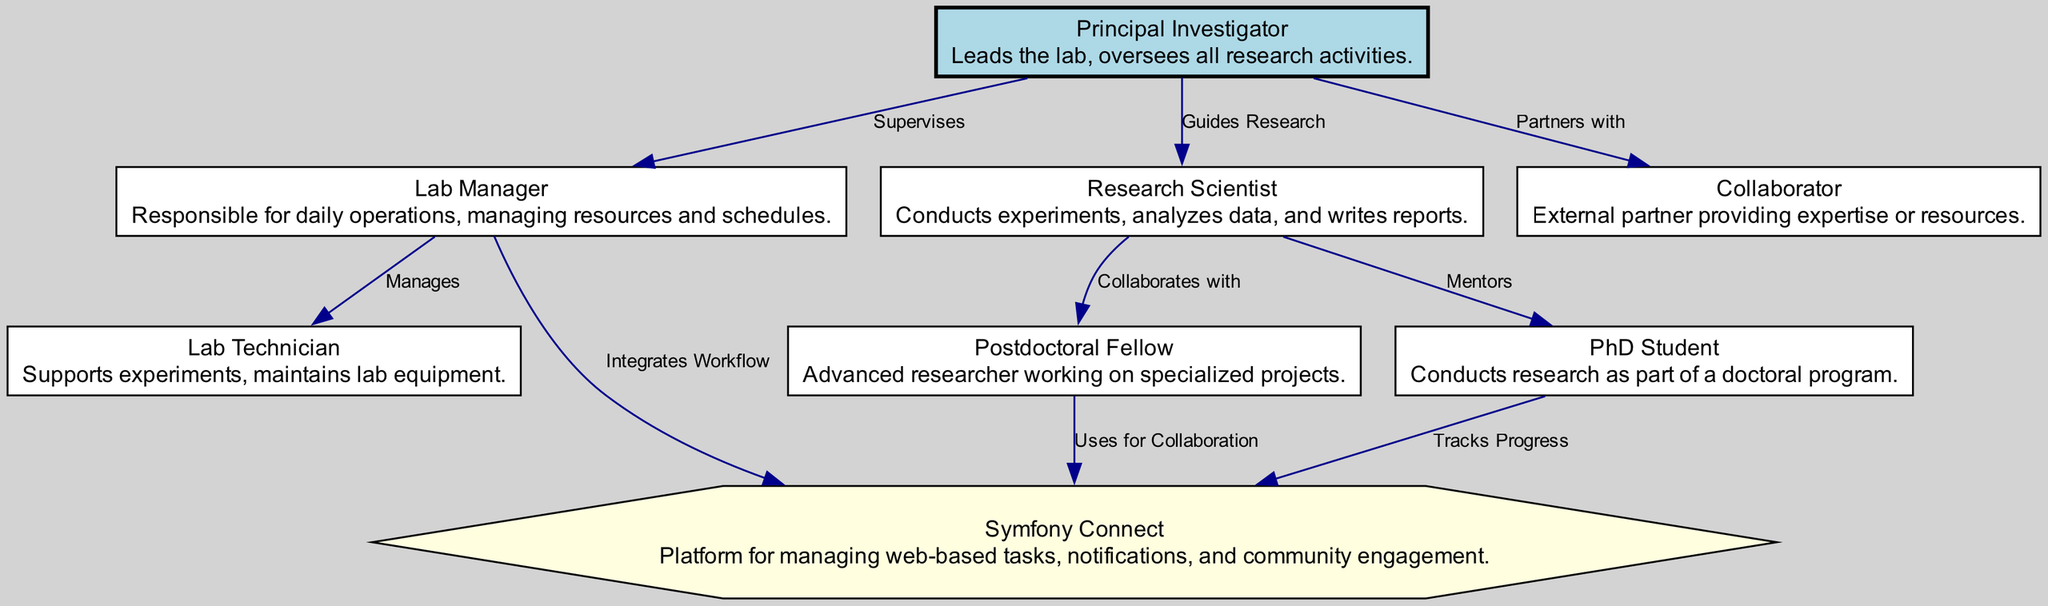What is the role of the Principal Investigator? The diagram explicitly states that the Principal Investigator "Leads the lab, oversees all research activities." Therefore, the answer is directly drawn from the role description next to this node.
Answer: Leads the lab, oversees all research activities How many nodes are present in the diagram? By counting the nodes listed in the "nodes" section of the data, we find there are 8 unique identifiers, each representing different roles within the lab structure. This count gives us the total number of nodes in the diagram.
Answer: 8 Who does the Lab Manager manage? The diagram indicates that the Lab Manager "Manages" the Lab Technician, establishing a direct relationship where the Lab Manager is responsible for overseeing the Lab Technician's work and activities.
Answer: Lab Technician What is the relationship between the Principal Investigator and the Collaborator? The diagram specifies that the Principal Investigator "Partners with" the Collaborator, indicating a collaborative relationship where both parties work together. This is explicitly articulated in the edges section where this connection is detailed.
Answer: Partners with Which node uses Symphony Connect for collaboration? According to the diagram, it states that the Postdoctoral Fellow "Uses for Collaboration" in relation to Symphony Connect, indicating their use of this platform for collaborative purposes and interactions.
Answer: Postdoctoral Fellow How many connections (edges) are there in the diagram? By reviewing the edges detailed in the data, we count a total of 8 connections that illustrate the relationships and workflows between different roles in the lab structure.
Answer: 8 Which role tracks progress using Symphony Connect? The role of the PhD Student is directly indicated in the diagram as one that "Tracks Progress" using Symphony Connect, showing their engagement with this platform for managing their research workflow.
Answer: PhD Student Who does the Research Scientist mentor? The diagram reveals the connection where the Research Scientist "Mentors" the PhD Student, indicating a guiding role the Research Scientist has over the PhD Student's research activities and development.
Answer: PhD Student 